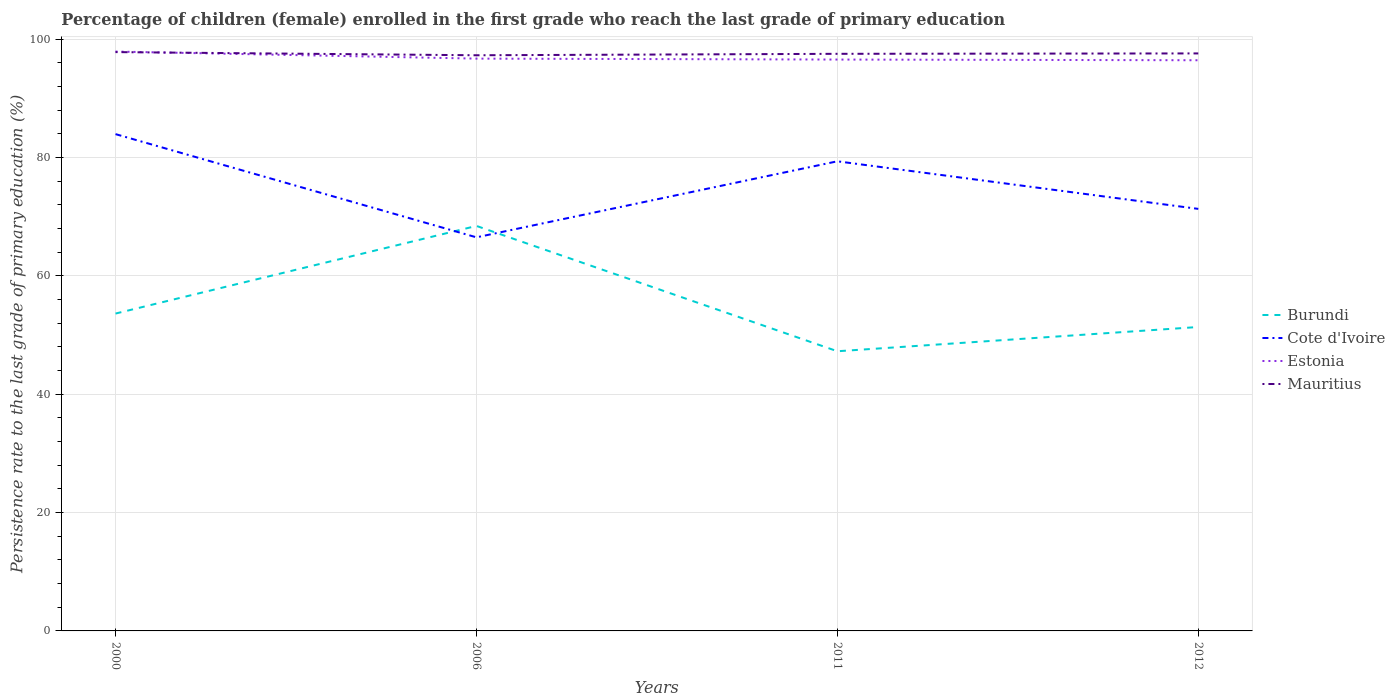How many different coloured lines are there?
Give a very brief answer. 4. Across all years, what is the maximum persistence rate of children in Mauritius?
Give a very brief answer. 97.3. In which year was the persistence rate of children in Mauritius maximum?
Keep it short and to the point. 2006. What is the total persistence rate of children in Burundi in the graph?
Your answer should be compact. -14.81. What is the difference between the highest and the second highest persistence rate of children in Burundi?
Offer a terse response. 21.18. How many lines are there?
Provide a succinct answer. 4. How many years are there in the graph?
Give a very brief answer. 4. Does the graph contain any zero values?
Your answer should be compact. No. Where does the legend appear in the graph?
Provide a short and direct response. Center right. How many legend labels are there?
Provide a succinct answer. 4. How are the legend labels stacked?
Provide a succinct answer. Vertical. What is the title of the graph?
Keep it short and to the point. Percentage of children (female) enrolled in the first grade who reach the last grade of primary education. What is the label or title of the Y-axis?
Your answer should be compact. Persistence rate to the last grade of primary education (%). What is the Persistence rate to the last grade of primary education (%) of Burundi in 2000?
Provide a succinct answer. 53.64. What is the Persistence rate to the last grade of primary education (%) in Cote d'Ivoire in 2000?
Your response must be concise. 83.97. What is the Persistence rate to the last grade of primary education (%) in Estonia in 2000?
Make the answer very short. 97.93. What is the Persistence rate to the last grade of primary education (%) in Mauritius in 2000?
Offer a terse response. 97.83. What is the Persistence rate to the last grade of primary education (%) in Burundi in 2006?
Ensure brevity in your answer.  68.45. What is the Persistence rate to the last grade of primary education (%) of Cote d'Ivoire in 2006?
Your response must be concise. 66.53. What is the Persistence rate to the last grade of primary education (%) of Estonia in 2006?
Your response must be concise. 96.73. What is the Persistence rate to the last grade of primary education (%) of Mauritius in 2006?
Your answer should be very brief. 97.3. What is the Persistence rate to the last grade of primary education (%) of Burundi in 2011?
Make the answer very short. 47.27. What is the Persistence rate to the last grade of primary education (%) in Cote d'Ivoire in 2011?
Offer a very short reply. 79.38. What is the Persistence rate to the last grade of primary education (%) in Estonia in 2011?
Provide a succinct answer. 96.57. What is the Persistence rate to the last grade of primary education (%) of Mauritius in 2011?
Provide a short and direct response. 97.54. What is the Persistence rate to the last grade of primary education (%) of Burundi in 2012?
Offer a very short reply. 51.37. What is the Persistence rate to the last grade of primary education (%) of Cote d'Ivoire in 2012?
Your answer should be compact. 71.33. What is the Persistence rate to the last grade of primary education (%) of Estonia in 2012?
Keep it short and to the point. 96.46. What is the Persistence rate to the last grade of primary education (%) in Mauritius in 2012?
Keep it short and to the point. 97.61. Across all years, what is the maximum Persistence rate to the last grade of primary education (%) of Burundi?
Provide a short and direct response. 68.45. Across all years, what is the maximum Persistence rate to the last grade of primary education (%) in Cote d'Ivoire?
Ensure brevity in your answer.  83.97. Across all years, what is the maximum Persistence rate to the last grade of primary education (%) in Estonia?
Make the answer very short. 97.93. Across all years, what is the maximum Persistence rate to the last grade of primary education (%) of Mauritius?
Your answer should be very brief. 97.83. Across all years, what is the minimum Persistence rate to the last grade of primary education (%) in Burundi?
Provide a short and direct response. 47.27. Across all years, what is the minimum Persistence rate to the last grade of primary education (%) in Cote d'Ivoire?
Make the answer very short. 66.53. Across all years, what is the minimum Persistence rate to the last grade of primary education (%) of Estonia?
Keep it short and to the point. 96.46. Across all years, what is the minimum Persistence rate to the last grade of primary education (%) of Mauritius?
Make the answer very short. 97.3. What is the total Persistence rate to the last grade of primary education (%) in Burundi in the graph?
Offer a very short reply. 220.73. What is the total Persistence rate to the last grade of primary education (%) of Cote d'Ivoire in the graph?
Make the answer very short. 301.21. What is the total Persistence rate to the last grade of primary education (%) in Estonia in the graph?
Your answer should be compact. 387.69. What is the total Persistence rate to the last grade of primary education (%) of Mauritius in the graph?
Your answer should be very brief. 390.29. What is the difference between the Persistence rate to the last grade of primary education (%) in Burundi in 2000 and that in 2006?
Your answer should be compact. -14.81. What is the difference between the Persistence rate to the last grade of primary education (%) of Cote d'Ivoire in 2000 and that in 2006?
Ensure brevity in your answer.  17.44. What is the difference between the Persistence rate to the last grade of primary education (%) in Estonia in 2000 and that in 2006?
Your response must be concise. 1.19. What is the difference between the Persistence rate to the last grade of primary education (%) of Mauritius in 2000 and that in 2006?
Ensure brevity in your answer.  0.53. What is the difference between the Persistence rate to the last grade of primary education (%) in Burundi in 2000 and that in 2011?
Offer a terse response. 6.37. What is the difference between the Persistence rate to the last grade of primary education (%) in Cote d'Ivoire in 2000 and that in 2011?
Offer a very short reply. 4.59. What is the difference between the Persistence rate to the last grade of primary education (%) in Estonia in 2000 and that in 2011?
Provide a short and direct response. 1.35. What is the difference between the Persistence rate to the last grade of primary education (%) of Mauritius in 2000 and that in 2011?
Your response must be concise. 0.29. What is the difference between the Persistence rate to the last grade of primary education (%) in Burundi in 2000 and that in 2012?
Provide a succinct answer. 2.27. What is the difference between the Persistence rate to the last grade of primary education (%) in Cote d'Ivoire in 2000 and that in 2012?
Offer a terse response. 12.64. What is the difference between the Persistence rate to the last grade of primary education (%) in Estonia in 2000 and that in 2012?
Your answer should be very brief. 1.47. What is the difference between the Persistence rate to the last grade of primary education (%) of Mauritius in 2000 and that in 2012?
Provide a succinct answer. 0.22. What is the difference between the Persistence rate to the last grade of primary education (%) in Burundi in 2006 and that in 2011?
Your response must be concise. 21.18. What is the difference between the Persistence rate to the last grade of primary education (%) of Cote d'Ivoire in 2006 and that in 2011?
Keep it short and to the point. -12.85. What is the difference between the Persistence rate to the last grade of primary education (%) of Estonia in 2006 and that in 2011?
Your answer should be very brief. 0.16. What is the difference between the Persistence rate to the last grade of primary education (%) of Mauritius in 2006 and that in 2011?
Provide a short and direct response. -0.24. What is the difference between the Persistence rate to the last grade of primary education (%) of Burundi in 2006 and that in 2012?
Give a very brief answer. 17.08. What is the difference between the Persistence rate to the last grade of primary education (%) of Cote d'Ivoire in 2006 and that in 2012?
Your response must be concise. -4.81. What is the difference between the Persistence rate to the last grade of primary education (%) of Estonia in 2006 and that in 2012?
Your answer should be very brief. 0.27. What is the difference between the Persistence rate to the last grade of primary education (%) in Mauritius in 2006 and that in 2012?
Ensure brevity in your answer.  -0.31. What is the difference between the Persistence rate to the last grade of primary education (%) of Burundi in 2011 and that in 2012?
Your answer should be very brief. -4.1. What is the difference between the Persistence rate to the last grade of primary education (%) in Cote d'Ivoire in 2011 and that in 2012?
Ensure brevity in your answer.  8.04. What is the difference between the Persistence rate to the last grade of primary education (%) in Estonia in 2011 and that in 2012?
Ensure brevity in your answer.  0.12. What is the difference between the Persistence rate to the last grade of primary education (%) in Mauritius in 2011 and that in 2012?
Provide a succinct answer. -0.07. What is the difference between the Persistence rate to the last grade of primary education (%) of Burundi in 2000 and the Persistence rate to the last grade of primary education (%) of Cote d'Ivoire in 2006?
Give a very brief answer. -12.88. What is the difference between the Persistence rate to the last grade of primary education (%) in Burundi in 2000 and the Persistence rate to the last grade of primary education (%) in Estonia in 2006?
Offer a very short reply. -43.09. What is the difference between the Persistence rate to the last grade of primary education (%) in Burundi in 2000 and the Persistence rate to the last grade of primary education (%) in Mauritius in 2006?
Make the answer very short. -43.66. What is the difference between the Persistence rate to the last grade of primary education (%) in Cote d'Ivoire in 2000 and the Persistence rate to the last grade of primary education (%) in Estonia in 2006?
Ensure brevity in your answer.  -12.76. What is the difference between the Persistence rate to the last grade of primary education (%) in Cote d'Ivoire in 2000 and the Persistence rate to the last grade of primary education (%) in Mauritius in 2006?
Keep it short and to the point. -13.33. What is the difference between the Persistence rate to the last grade of primary education (%) in Estonia in 2000 and the Persistence rate to the last grade of primary education (%) in Mauritius in 2006?
Offer a very short reply. 0.63. What is the difference between the Persistence rate to the last grade of primary education (%) of Burundi in 2000 and the Persistence rate to the last grade of primary education (%) of Cote d'Ivoire in 2011?
Ensure brevity in your answer.  -25.74. What is the difference between the Persistence rate to the last grade of primary education (%) in Burundi in 2000 and the Persistence rate to the last grade of primary education (%) in Estonia in 2011?
Offer a terse response. -42.93. What is the difference between the Persistence rate to the last grade of primary education (%) in Burundi in 2000 and the Persistence rate to the last grade of primary education (%) in Mauritius in 2011?
Keep it short and to the point. -43.9. What is the difference between the Persistence rate to the last grade of primary education (%) of Cote d'Ivoire in 2000 and the Persistence rate to the last grade of primary education (%) of Estonia in 2011?
Ensure brevity in your answer.  -12.61. What is the difference between the Persistence rate to the last grade of primary education (%) of Cote d'Ivoire in 2000 and the Persistence rate to the last grade of primary education (%) of Mauritius in 2011?
Ensure brevity in your answer.  -13.57. What is the difference between the Persistence rate to the last grade of primary education (%) in Estonia in 2000 and the Persistence rate to the last grade of primary education (%) in Mauritius in 2011?
Make the answer very short. 0.38. What is the difference between the Persistence rate to the last grade of primary education (%) in Burundi in 2000 and the Persistence rate to the last grade of primary education (%) in Cote d'Ivoire in 2012?
Provide a short and direct response. -17.69. What is the difference between the Persistence rate to the last grade of primary education (%) in Burundi in 2000 and the Persistence rate to the last grade of primary education (%) in Estonia in 2012?
Ensure brevity in your answer.  -42.82. What is the difference between the Persistence rate to the last grade of primary education (%) in Burundi in 2000 and the Persistence rate to the last grade of primary education (%) in Mauritius in 2012?
Offer a terse response. -43.97. What is the difference between the Persistence rate to the last grade of primary education (%) of Cote d'Ivoire in 2000 and the Persistence rate to the last grade of primary education (%) of Estonia in 2012?
Offer a terse response. -12.49. What is the difference between the Persistence rate to the last grade of primary education (%) in Cote d'Ivoire in 2000 and the Persistence rate to the last grade of primary education (%) in Mauritius in 2012?
Provide a succinct answer. -13.64. What is the difference between the Persistence rate to the last grade of primary education (%) of Estonia in 2000 and the Persistence rate to the last grade of primary education (%) of Mauritius in 2012?
Provide a short and direct response. 0.31. What is the difference between the Persistence rate to the last grade of primary education (%) in Burundi in 2006 and the Persistence rate to the last grade of primary education (%) in Cote d'Ivoire in 2011?
Provide a succinct answer. -10.92. What is the difference between the Persistence rate to the last grade of primary education (%) of Burundi in 2006 and the Persistence rate to the last grade of primary education (%) of Estonia in 2011?
Give a very brief answer. -28.12. What is the difference between the Persistence rate to the last grade of primary education (%) in Burundi in 2006 and the Persistence rate to the last grade of primary education (%) in Mauritius in 2011?
Your answer should be very brief. -29.09. What is the difference between the Persistence rate to the last grade of primary education (%) of Cote d'Ivoire in 2006 and the Persistence rate to the last grade of primary education (%) of Estonia in 2011?
Keep it short and to the point. -30.05. What is the difference between the Persistence rate to the last grade of primary education (%) of Cote d'Ivoire in 2006 and the Persistence rate to the last grade of primary education (%) of Mauritius in 2011?
Offer a terse response. -31.02. What is the difference between the Persistence rate to the last grade of primary education (%) of Estonia in 2006 and the Persistence rate to the last grade of primary education (%) of Mauritius in 2011?
Keep it short and to the point. -0.81. What is the difference between the Persistence rate to the last grade of primary education (%) in Burundi in 2006 and the Persistence rate to the last grade of primary education (%) in Cote d'Ivoire in 2012?
Offer a very short reply. -2.88. What is the difference between the Persistence rate to the last grade of primary education (%) of Burundi in 2006 and the Persistence rate to the last grade of primary education (%) of Estonia in 2012?
Make the answer very short. -28. What is the difference between the Persistence rate to the last grade of primary education (%) of Burundi in 2006 and the Persistence rate to the last grade of primary education (%) of Mauritius in 2012?
Your answer should be very brief. -29.16. What is the difference between the Persistence rate to the last grade of primary education (%) of Cote d'Ivoire in 2006 and the Persistence rate to the last grade of primary education (%) of Estonia in 2012?
Keep it short and to the point. -29.93. What is the difference between the Persistence rate to the last grade of primary education (%) in Cote d'Ivoire in 2006 and the Persistence rate to the last grade of primary education (%) in Mauritius in 2012?
Your answer should be compact. -31.09. What is the difference between the Persistence rate to the last grade of primary education (%) of Estonia in 2006 and the Persistence rate to the last grade of primary education (%) of Mauritius in 2012?
Provide a short and direct response. -0.88. What is the difference between the Persistence rate to the last grade of primary education (%) of Burundi in 2011 and the Persistence rate to the last grade of primary education (%) of Cote d'Ivoire in 2012?
Keep it short and to the point. -24.06. What is the difference between the Persistence rate to the last grade of primary education (%) of Burundi in 2011 and the Persistence rate to the last grade of primary education (%) of Estonia in 2012?
Give a very brief answer. -49.19. What is the difference between the Persistence rate to the last grade of primary education (%) of Burundi in 2011 and the Persistence rate to the last grade of primary education (%) of Mauritius in 2012?
Offer a very short reply. -50.34. What is the difference between the Persistence rate to the last grade of primary education (%) in Cote d'Ivoire in 2011 and the Persistence rate to the last grade of primary education (%) in Estonia in 2012?
Ensure brevity in your answer.  -17.08. What is the difference between the Persistence rate to the last grade of primary education (%) in Cote d'Ivoire in 2011 and the Persistence rate to the last grade of primary education (%) in Mauritius in 2012?
Make the answer very short. -18.23. What is the difference between the Persistence rate to the last grade of primary education (%) of Estonia in 2011 and the Persistence rate to the last grade of primary education (%) of Mauritius in 2012?
Make the answer very short. -1.04. What is the average Persistence rate to the last grade of primary education (%) of Burundi per year?
Make the answer very short. 55.18. What is the average Persistence rate to the last grade of primary education (%) in Cote d'Ivoire per year?
Offer a terse response. 75.3. What is the average Persistence rate to the last grade of primary education (%) in Estonia per year?
Give a very brief answer. 96.92. What is the average Persistence rate to the last grade of primary education (%) of Mauritius per year?
Make the answer very short. 97.57. In the year 2000, what is the difference between the Persistence rate to the last grade of primary education (%) in Burundi and Persistence rate to the last grade of primary education (%) in Cote d'Ivoire?
Your answer should be compact. -30.33. In the year 2000, what is the difference between the Persistence rate to the last grade of primary education (%) in Burundi and Persistence rate to the last grade of primary education (%) in Estonia?
Your response must be concise. -44.28. In the year 2000, what is the difference between the Persistence rate to the last grade of primary education (%) of Burundi and Persistence rate to the last grade of primary education (%) of Mauritius?
Make the answer very short. -44.19. In the year 2000, what is the difference between the Persistence rate to the last grade of primary education (%) of Cote d'Ivoire and Persistence rate to the last grade of primary education (%) of Estonia?
Your answer should be compact. -13.96. In the year 2000, what is the difference between the Persistence rate to the last grade of primary education (%) in Cote d'Ivoire and Persistence rate to the last grade of primary education (%) in Mauritius?
Provide a short and direct response. -13.86. In the year 2000, what is the difference between the Persistence rate to the last grade of primary education (%) in Estonia and Persistence rate to the last grade of primary education (%) in Mauritius?
Ensure brevity in your answer.  0.09. In the year 2006, what is the difference between the Persistence rate to the last grade of primary education (%) in Burundi and Persistence rate to the last grade of primary education (%) in Cote d'Ivoire?
Your answer should be compact. 1.93. In the year 2006, what is the difference between the Persistence rate to the last grade of primary education (%) in Burundi and Persistence rate to the last grade of primary education (%) in Estonia?
Offer a terse response. -28.28. In the year 2006, what is the difference between the Persistence rate to the last grade of primary education (%) of Burundi and Persistence rate to the last grade of primary education (%) of Mauritius?
Offer a very short reply. -28.85. In the year 2006, what is the difference between the Persistence rate to the last grade of primary education (%) in Cote d'Ivoire and Persistence rate to the last grade of primary education (%) in Estonia?
Offer a terse response. -30.21. In the year 2006, what is the difference between the Persistence rate to the last grade of primary education (%) in Cote d'Ivoire and Persistence rate to the last grade of primary education (%) in Mauritius?
Your answer should be very brief. -30.77. In the year 2006, what is the difference between the Persistence rate to the last grade of primary education (%) in Estonia and Persistence rate to the last grade of primary education (%) in Mauritius?
Keep it short and to the point. -0.57. In the year 2011, what is the difference between the Persistence rate to the last grade of primary education (%) of Burundi and Persistence rate to the last grade of primary education (%) of Cote d'Ivoire?
Offer a very short reply. -32.11. In the year 2011, what is the difference between the Persistence rate to the last grade of primary education (%) in Burundi and Persistence rate to the last grade of primary education (%) in Estonia?
Give a very brief answer. -49.3. In the year 2011, what is the difference between the Persistence rate to the last grade of primary education (%) of Burundi and Persistence rate to the last grade of primary education (%) of Mauritius?
Your response must be concise. -50.27. In the year 2011, what is the difference between the Persistence rate to the last grade of primary education (%) in Cote d'Ivoire and Persistence rate to the last grade of primary education (%) in Estonia?
Provide a succinct answer. -17.2. In the year 2011, what is the difference between the Persistence rate to the last grade of primary education (%) in Cote d'Ivoire and Persistence rate to the last grade of primary education (%) in Mauritius?
Your response must be concise. -18.17. In the year 2011, what is the difference between the Persistence rate to the last grade of primary education (%) in Estonia and Persistence rate to the last grade of primary education (%) in Mauritius?
Ensure brevity in your answer.  -0.97. In the year 2012, what is the difference between the Persistence rate to the last grade of primary education (%) of Burundi and Persistence rate to the last grade of primary education (%) of Cote d'Ivoire?
Provide a short and direct response. -19.96. In the year 2012, what is the difference between the Persistence rate to the last grade of primary education (%) of Burundi and Persistence rate to the last grade of primary education (%) of Estonia?
Keep it short and to the point. -45.09. In the year 2012, what is the difference between the Persistence rate to the last grade of primary education (%) in Burundi and Persistence rate to the last grade of primary education (%) in Mauritius?
Provide a short and direct response. -46.24. In the year 2012, what is the difference between the Persistence rate to the last grade of primary education (%) of Cote d'Ivoire and Persistence rate to the last grade of primary education (%) of Estonia?
Provide a succinct answer. -25.12. In the year 2012, what is the difference between the Persistence rate to the last grade of primary education (%) of Cote d'Ivoire and Persistence rate to the last grade of primary education (%) of Mauritius?
Give a very brief answer. -26.28. In the year 2012, what is the difference between the Persistence rate to the last grade of primary education (%) of Estonia and Persistence rate to the last grade of primary education (%) of Mauritius?
Give a very brief answer. -1.15. What is the ratio of the Persistence rate to the last grade of primary education (%) of Burundi in 2000 to that in 2006?
Offer a terse response. 0.78. What is the ratio of the Persistence rate to the last grade of primary education (%) of Cote d'Ivoire in 2000 to that in 2006?
Keep it short and to the point. 1.26. What is the ratio of the Persistence rate to the last grade of primary education (%) of Estonia in 2000 to that in 2006?
Provide a short and direct response. 1.01. What is the ratio of the Persistence rate to the last grade of primary education (%) in Mauritius in 2000 to that in 2006?
Offer a very short reply. 1.01. What is the ratio of the Persistence rate to the last grade of primary education (%) of Burundi in 2000 to that in 2011?
Your answer should be compact. 1.13. What is the ratio of the Persistence rate to the last grade of primary education (%) of Cote d'Ivoire in 2000 to that in 2011?
Provide a succinct answer. 1.06. What is the ratio of the Persistence rate to the last grade of primary education (%) in Estonia in 2000 to that in 2011?
Provide a short and direct response. 1.01. What is the ratio of the Persistence rate to the last grade of primary education (%) of Mauritius in 2000 to that in 2011?
Keep it short and to the point. 1. What is the ratio of the Persistence rate to the last grade of primary education (%) in Burundi in 2000 to that in 2012?
Ensure brevity in your answer.  1.04. What is the ratio of the Persistence rate to the last grade of primary education (%) of Cote d'Ivoire in 2000 to that in 2012?
Ensure brevity in your answer.  1.18. What is the ratio of the Persistence rate to the last grade of primary education (%) of Estonia in 2000 to that in 2012?
Your answer should be compact. 1.02. What is the ratio of the Persistence rate to the last grade of primary education (%) in Burundi in 2006 to that in 2011?
Offer a terse response. 1.45. What is the ratio of the Persistence rate to the last grade of primary education (%) in Cote d'Ivoire in 2006 to that in 2011?
Your answer should be compact. 0.84. What is the ratio of the Persistence rate to the last grade of primary education (%) of Burundi in 2006 to that in 2012?
Provide a succinct answer. 1.33. What is the ratio of the Persistence rate to the last grade of primary education (%) of Cote d'Ivoire in 2006 to that in 2012?
Make the answer very short. 0.93. What is the ratio of the Persistence rate to the last grade of primary education (%) in Burundi in 2011 to that in 2012?
Your answer should be compact. 0.92. What is the ratio of the Persistence rate to the last grade of primary education (%) of Cote d'Ivoire in 2011 to that in 2012?
Provide a short and direct response. 1.11. What is the difference between the highest and the second highest Persistence rate to the last grade of primary education (%) in Burundi?
Your answer should be compact. 14.81. What is the difference between the highest and the second highest Persistence rate to the last grade of primary education (%) in Cote d'Ivoire?
Provide a short and direct response. 4.59. What is the difference between the highest and the second highest Persistence rate to the last grade of primary education (%) in Estonia?
Provide a short and direct response. 1.19. What is the difference between the highest and the second highest Persistence rate to the last grade of primary education (%) in Mauritius?
Keep it short and to the point. 0.22. What is the difference between the highest and the lowest Persistence rate to the last grade of primary education (%) of Burundi?
Ensure brevity in your answer.  21.18. What is the difference between the highest and the lowest Persistence rate to the last grade of primary education (%) of Cote d'Ivoire?
Ensure brevity in your answer.  17.44. What is the difference between the highest and the lowest Persistence rate to the last grade of primary education (%) in Estonia?
Your response must be concise. 1.47. What is the difference between the highest and the lowest Persistence rate to the last grade of primary education (%) of Mauritius?
Offer a terse response. 0.53. 